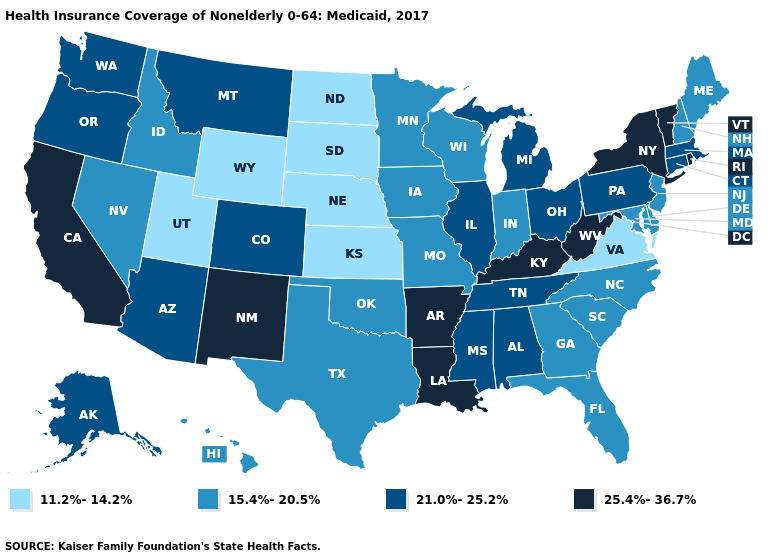Name the states that have a value in the range 25.4%-36.7%?
Keep it brief. Arkansas, California, Kentucky, Louisiana, New Mexico, New York, Rhode Island, Vermont, West Virginia. How many symbols are there in the legend?
Concise answer only. 4. What is the value of Missouri?
Give a very brief answer. 15.4%-20.5%. Name the states that have a value in the range 25.4%-36.7%?
Concise answer only. Arkansas, California, Kentucky, Louisiana, New Mexico, New York, Rhode Island, Vermont, West Virginia. Among the states that border Illinois , which have the highest value?
Write a very short answer. Kentucky. What is the highest value in states that border Kansas?
Give a very brief answer. 21.0%-25.2%. What is the lowest value in the Northeast?
Be succinct. 15.4%-20.5%. Name the states that have a value in the range 11.2%-14.2%?
Be succinct. Kansas, Nebraska, North Dakota, South Dakota, Utah, Virginia, Wyoming. Which states have the lowest value in the USA?
Be succinct. Kansas, Nebraska, North Dakota, South Dakota, Utah, Virginia, Wyoming. Does Wisconsin have the highest value in the MidWest?
Short answer required. No. Which states have the highest value in the USA?
Keep it brief. Arkansas, California, Kentucky, Louisiana, New Mexico, New York, Rhode Island, Vermont, West Virginia. What is the highest value in the USA?
Quick response, please. 25.4%-36.7%. Name the states that have a value in the range 25.4%-36.7%?
Be succinct. Arkansas, California, Kentucky, Louisiana, New Mexico, New York, Rhode Island, Vermont, West Virginia. Which states have the lowest value in the USA?
Give a very brief answer. Kansas, Nebraska, North Dakota, South Dakota, Utah, Virginia, Wyoming. What is the highest value in the MidWest ?
Quick response, please. 21.0%-25.2%. 